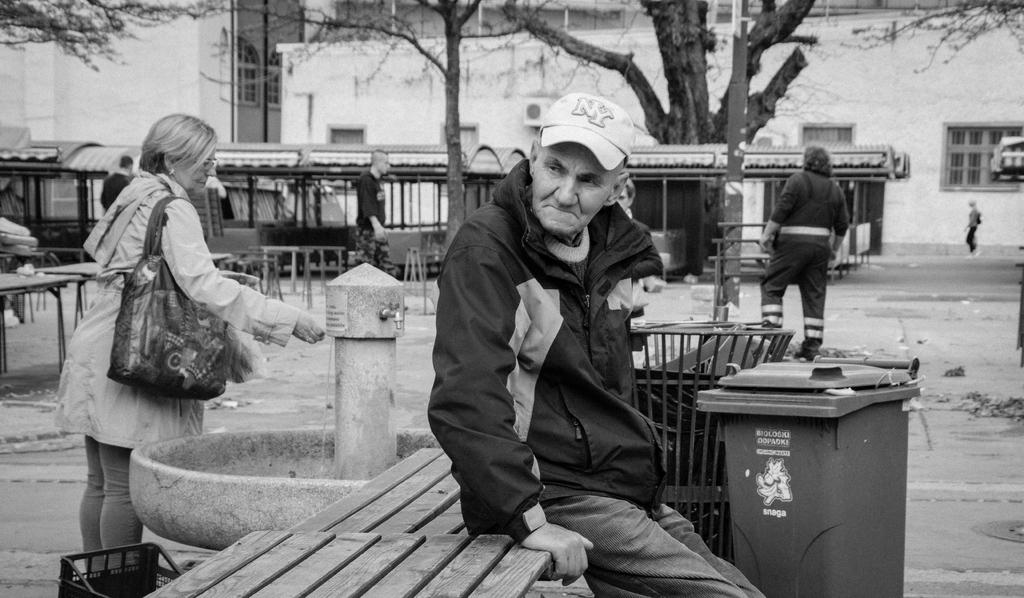What letters are on this old man's hat?
Offer a terse response. Ny. What word is under the picture on the trash can?
Your answer should be compact. Snaga. 